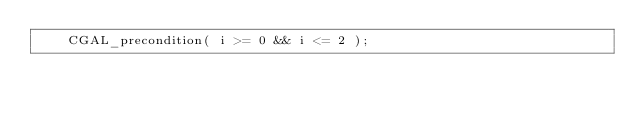Convert code to text. <code><loc_0><loc_0><loc_500><loc_500><_C_>    CGAL_precondition( i >= 0 && i <= 2 );</code> 